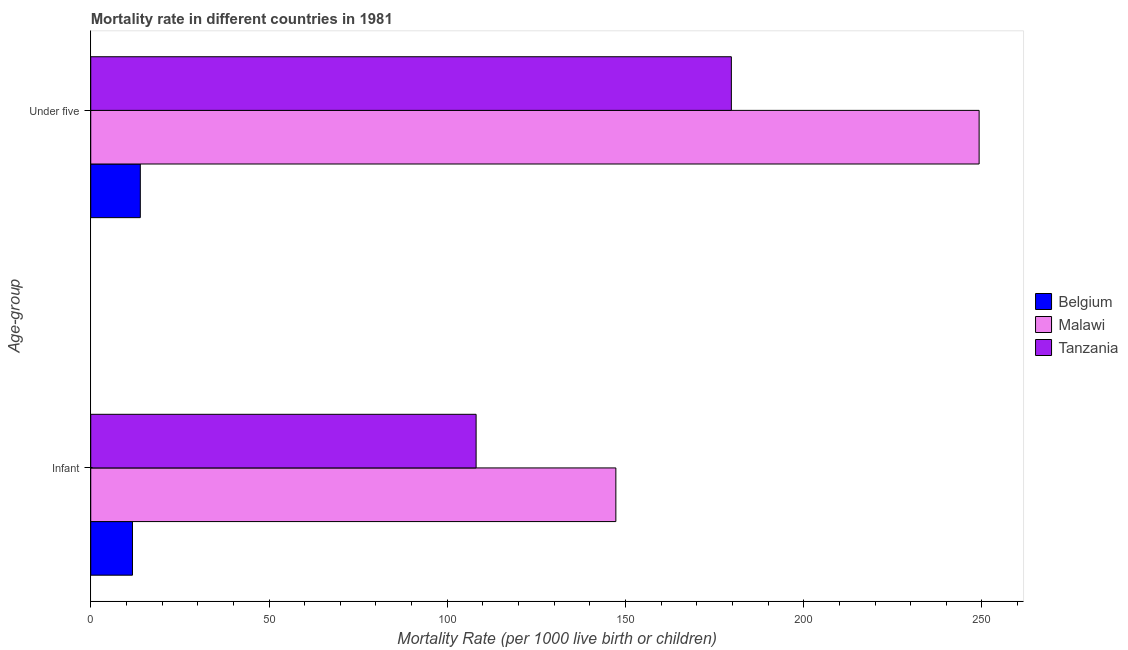How many different coloured bars are there?
Your response must be concise. 3. How many groups of bars are there?
Make the answer very short. 2. Are the number of bars on each tick of the Y-axis equal?
Make the answer very short. Yes. How many bars are there on the 1st tick from the bottom?
Provide a succinct answer. 3. What is the label of the 1st group of bars from the top?
Your response must be concise. Under five. What is the under-5 mortality rate in Belgium?
Provide a short and direct response. 13.9. Across all countries, what is the maximum infant mortality rate?
Offer a very short reply. 147.3. In which country was the under-5 mortality rate maximum?
Provide a short and direct response. Malawi. What is the total infant mortality rate in the graph?
Your answer should be compact. 267.1. What is the difference between the under-5 mortality rate in Malawi and that in Belgium?
Offer a very short reply. 235.3. What is the difference between the infant mortality rate in Tanzania and the under-5 mortality rate in Belgium?
Make the answer very short. 94.2. What is the average under-5 mortality rate per country?
Keep it short and to the point. 147.6. What is the difference between the under-5 mortality rate and infant mortality rate in Tanzania?
Ensure brevity in your answer.  71.6. In how many countries, is the under-5 mortality rate greater than 140 ?
Offer a very short reply. 2. What is the ratio of the under-5 mortality rate in Malawi to that in Belgium?
Provide a succinct answer. 17.93. Is the under-5 mortality rate in Malawi less than that in Belgium?
Your response must be concise. No. What does the 2nd bar from the top in Infant represents?
Make the answer very short. Malawi. What does the 2nd bar from the bottom in Under five represents?
Offer a very short reply. Malawi. Are all the bars in the graph horizontal?
Provide a succinct answer. Yes. Does the graph contain grids?
Give a very brief answer. No. How many legend labels are there?
Make the answer very short. 3. What is the title of the graph?
Ensure brevity in your answer.  Mortality rate in different countries in 1981. What is the label or title of the X-axis?
Provide a short and direct response. Mortality Rate (per 1000 live birth or children). What is the label or title of the Y-axis?
Offer a very short reply. Age-group. What is the Mortality Rate (per 1000 live birth or children) of Belgium in Infant?
Your response must be concise. 11.7. What is the Mortality Rate (per 1000 live birth or children) of Malawi in Infant?
Make the answer very short. 147.3. What is the Mortality Rate (per 1000 live birth or children) of Tanzania in Infant?
Offer a terse response. 108.1. What is the Mortality Rate (per 1000 live birth or children) in Belgium in Under five?
Make the answer very short. 13.9. What is the Mortality Rate (per 1000 live birth or children) of Malawi in Under five?
Keep it short and to the point. 249.2. What is the Mortality Rate (per 1000 live birth or children) of Tanzania in Under five?
Give a very brief answer. 179.7. Across all Age-group, what is the maximum Mortality Rate (per 1000 live birth or children) in Belgium?
Provide a short and direct response. 13.9. Across all Age-group, what is the maximum Mortality Rate (per 1000 live birth or children) in Malawi?
Offer a very short reply. 249.2. Across all Age-group, what is the maximum Mortality Rate (per 1000 live birth or children) in Tanzania?
Offer a terse response. 179.7. Across all Age-group, what is the minimum Mortality Rate (per 1000 live birth or children) in Belgium?
Give a very brief answer. 11.7. Across all Age-group, what is the minimum Mortality Rate (per 1000 live birth or children) in Malawi?
Give a very brief answer. 147.3. Across all Age-group, what is the minimum Mortality Rate (per 1000 live birth or children) of Tanzania?
Provide a short and direct response. 108.1. What is the total Mortality Rate (per 1000 live birth or children) of Belgium in the graph?
Offer a terse response. 25.6. What is the total Mortality Rate (per 1000 live birth or children) in Malawi in the graph?
Offer a terse response. 396.5. What is the total Mortality Rate (per 1000 live birth or children) in Tanzania in the graph?
Keep it short and to the point. 287.8. What is the difference between the Mortality Rate (per 1000 live birth or children) of Malawi in Infant and that in Under five?
Your answer should be compact. -101.9. What is the difference between the Mortality Rate (per 1000 live birth or children) in Tanzania in Infant and that in Under five?
Your response must be concise. -71.6. What is the difference between the Mortality Rate (per 1000 live birth or children) in Belgium in Infant and the Mortality Rate (per 1000 live birth or children) in Malawi in Under five?
Make the answer very short. -237.5. What is the difference between the Mortality Rate (per 1000 live birth or children) in Belgium in Infant and the Mortality Rate (per 1000 live birth or children) in Tanzania in Under five?
Give a very brief answer. -168. What is the difference between the Mortality Rate (per 1000 live birth or children) of Malawi in Infant and the Mortality Rate (per 1000 live birth or children) of Tanzania in Under five?
Your answer should be very brief. -32.4. What is the average Mortality Rate (per 1000 live birth or children) in Malawi per Age-group?
Make the answer very short. 198.25. What is the average Mortality Rate (per 1000 live birth or children) in Tanzania per Age-group?
Make the answer very short. 143.9. What is the difference between the Mortality Rate (per 1000 live birth or children) of Belgium and Mortality Rate (per 1000 live birth or children) of Malawi in Infant?
Provide a succinct answer. -135.6. What is the difference between the Mortality Rate (per 1000 live birth or children) in Belgium and Mortality Rate (per 1000 live birth or children) in Tanzania in Infant?
Ensure brevity in your answer.  -96.4. What is the difference between the Mortality Rate (per 1000 live birth or children) in Malawi and Mortality Rate (per 1000 live birth or children) in Tanzania in Infant?
Make the answer very short. 39.2. What is the difference between the Mortality Rate (per 1000 live birth or children) of Belgium and Mortality Rate (per 1000 live birth or children) of Malawi in Under five?
Provide a short and direct response. -235.3. What is the difference between the Mortality Rate (per 1000 live birth or children) in Belgium and Mortality Rate (per 1000 live birth or children) in Tanzania in Under five?
Offer a terse response. -165.8. What is the difference between the Mortality Rate (per 1000 live birth or children) in Malawi and Mortality Rate (per 1000 live birth or children) in Tanzania in Under five?
Keep it short and to the point. 69.5. What is the ratio of the Mortality Rate (per 1000 live birth or children) in Belgium in Infant to that in Under five?
Make the answer very short. 0.84. What is the ratio of the Mortality Rate (per 1000 live birth or children) in Malawi in Infant to that in Under five?
Provide a succinct answer. 0.59. What is the ratio of the Mortality Rate (per 1000 live birth or children) in Tanzania in Infant to that in Under five?
Make the answer very short. 0.6. What is the difference between the highest and the second highest Mortality Rate (per 1000 live birth or children) of Malawi?
Your response must be concise. 101.9. What is the difference between the highest and the second highest Mortality Rate (per 1000 live birth or children) in Tanzania?
Make the answer very short. 71.6. What is the difference between the highest and the lowest Mortality Rate (per 1000 live birth or children) of Belgium?
Offer a terse response. 2.2. What is the difference between the highest and the lowest Mortality Rate (per 1000 live birth or children) of Malawi?
Offer a very short reply. 101.9. What is the difference between the highest and the lowest Mortality Rate (per 1000 live birth or children) in Tanzania?
Provide a short and direct response. 71.6. 